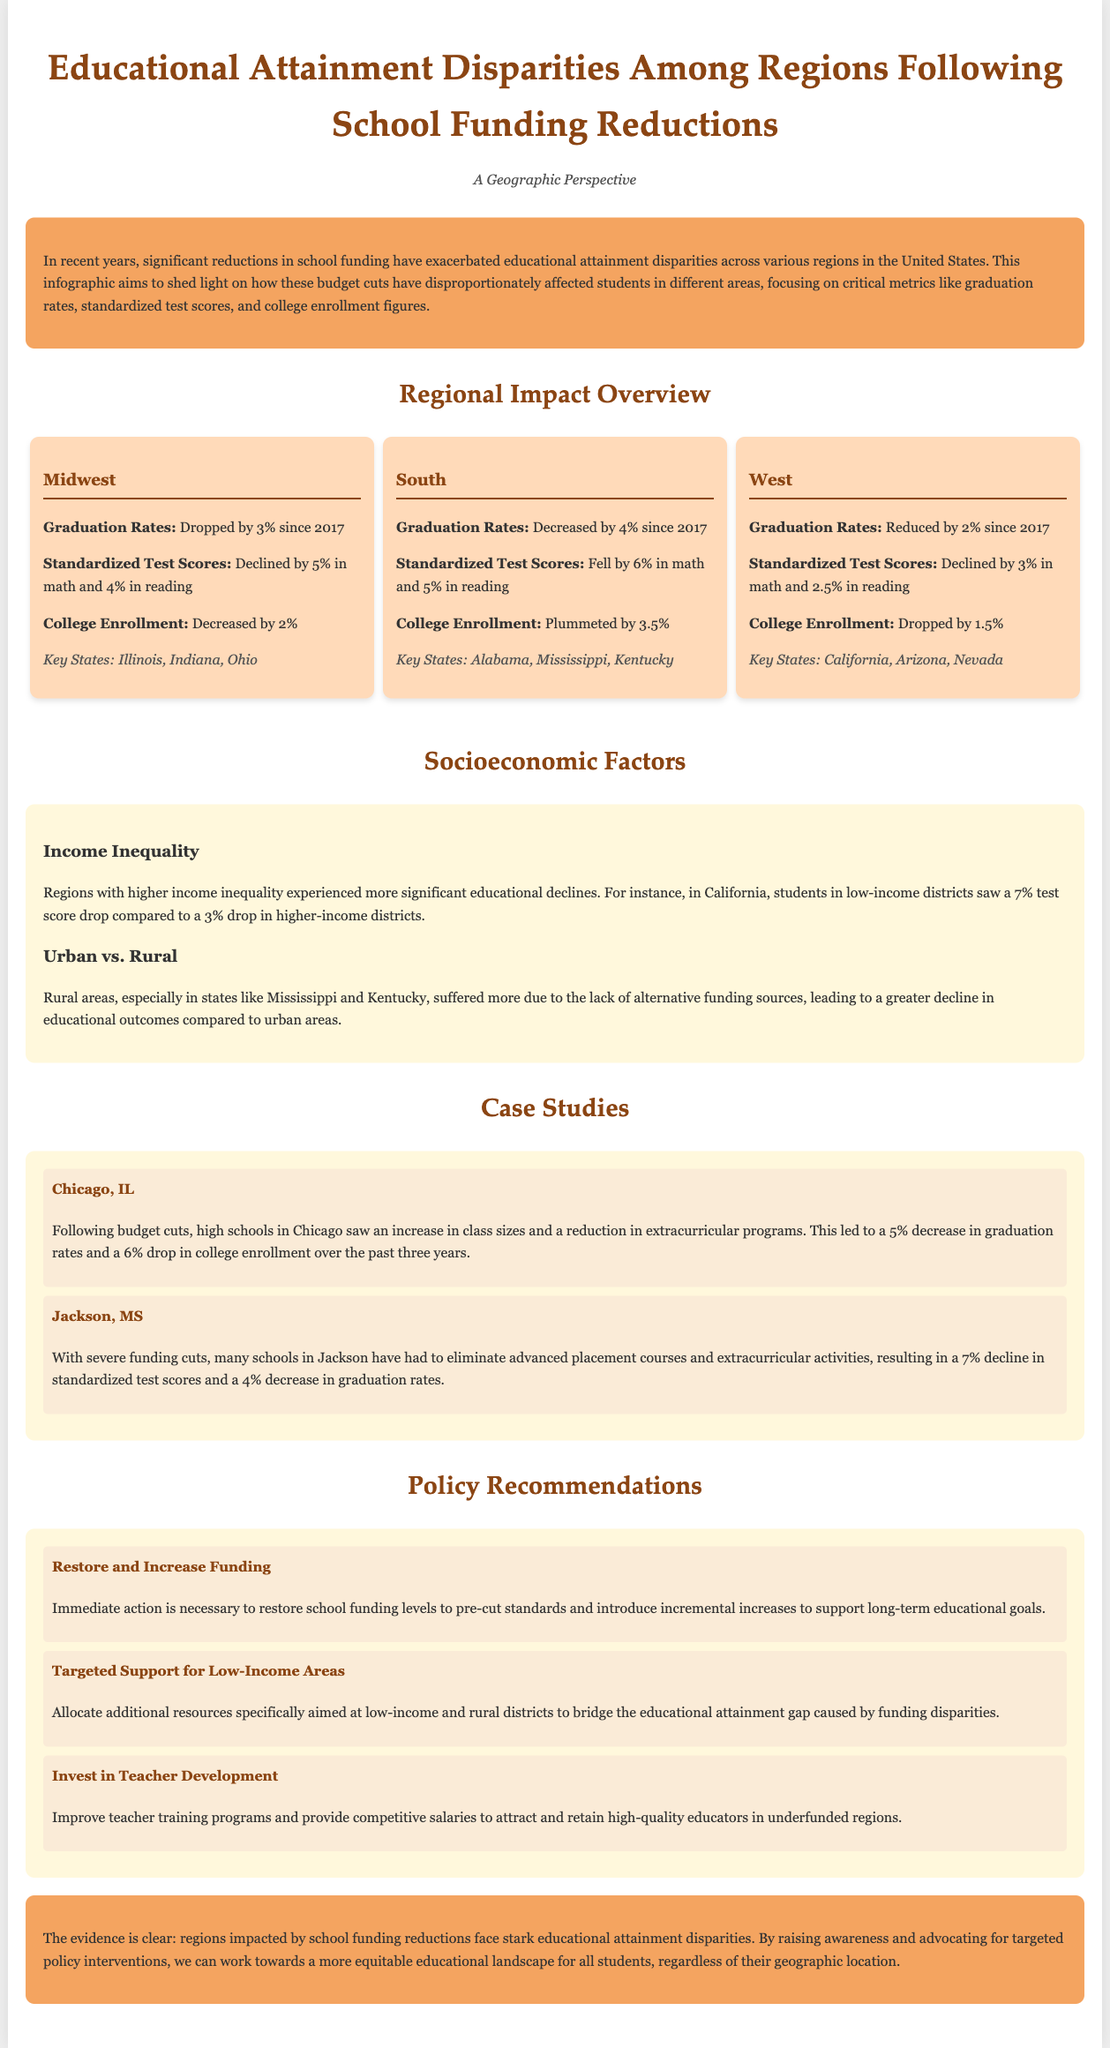What percentage did graduation rates drop in the Midwest? The document states that graduation rates dropped by 3% since 2017 in the Midwest.
Answer: 3% What was the decrease in college enrollment in the South? The South experienced a significant decrease in college enrollment, which is noted as plummeting by 3.5%.
Answer: 3.5% Which state saw a 7%test score drop in low-income districts? The document mentions California, where low-income districts experienced a 7% test score drop compared to higher-income districts.
Answer: California What does the case study on Jackson, MS highlight? The case study on Jackson, MS emphasizes severe funding cuts leading to a 7% decline in standardized test scores and a 4% decrease in graduation rates.
Answer: Advanced placement courses eliminated How has rural areas' educational decline compared to urban areas? The document indicates that rural areas, especially in Mississippi and Kentucky, suffered more due to lack of funding alternatives.
Answer: Higher decline What is one recommendation to address funding disparities? The document includes a recommendation to "Restore and Increase Funding" to address the disparities caused by previous reductions.
Answer: Restore and Increase Funding How much did standardized test scores decline in the West? The West saw a decline of 3% in math and 2.5% in reading for standardized test scores.
Answer: 3% in math, 2.5% in reading What impact did funding cuts have on Chicago high schools? In Chicago, funding cuts led to an increase in class sizes and reduction in extracurricular programs, resulting in a 5% decrease in graduation rates.
Answer: Increase in class sizes 